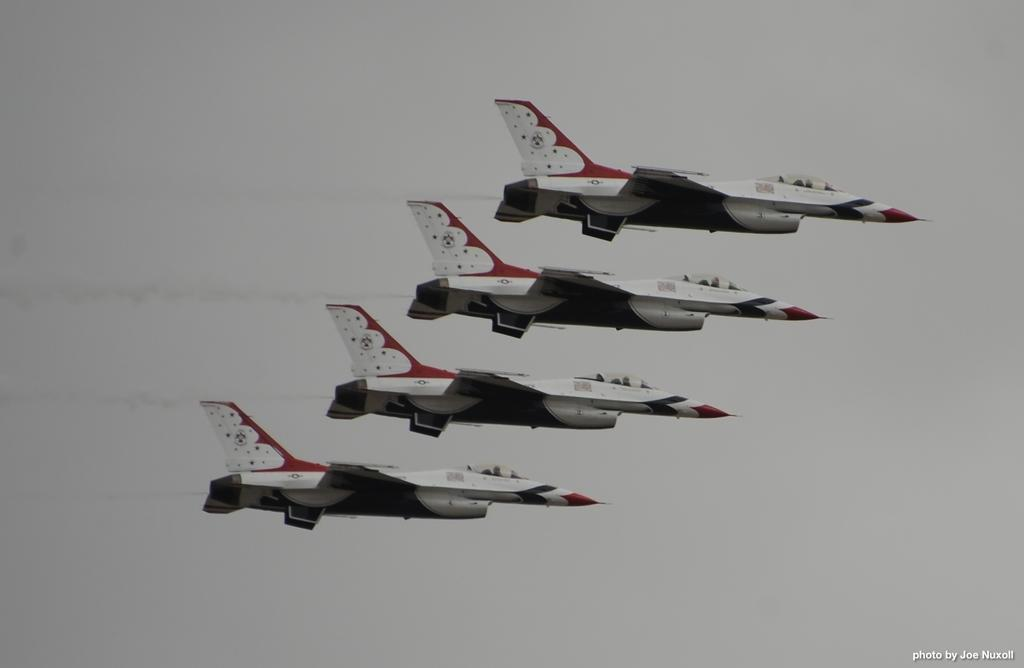How many jet planes are visible in the image? There are four jet planes in the image. What are the jet planes doing in the image? The jet planes are flying in the sky. Is there any additional information or marking in the image? Yes, there is a watermark in the bottom right corner of the image. Can you see any snails crawling on the jet planes in the image? No, there are no snails visible on the jet planes in the image. What type of industry is depicted in the image? The image does not depict any specific industry; it features four jet planes flying in the sky. 